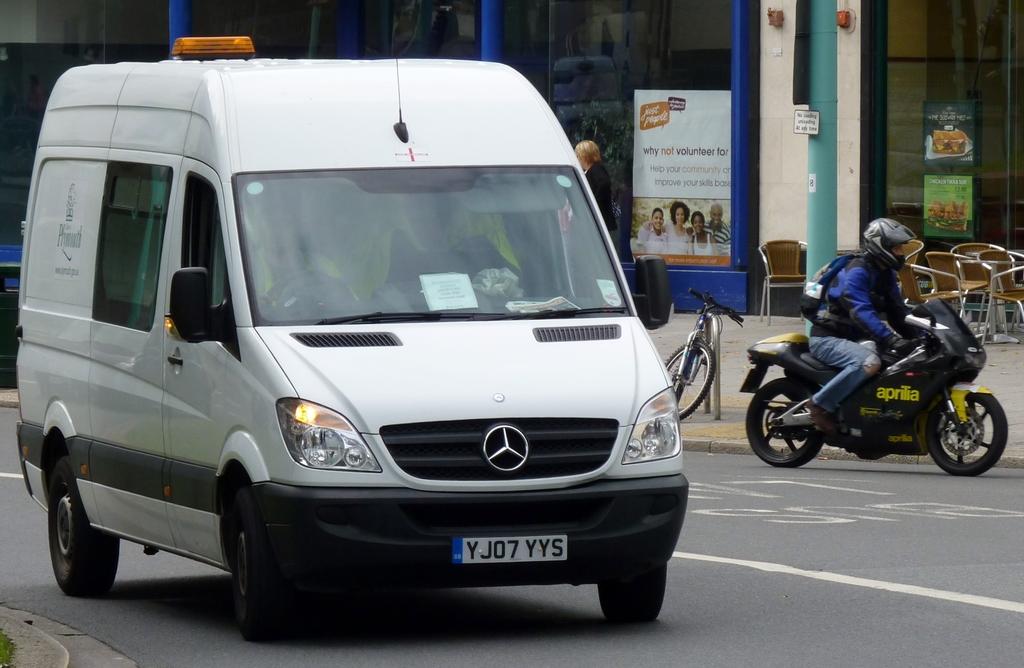What is the license plate?
Ensure brevity in your answer.  Yj07 yys. 